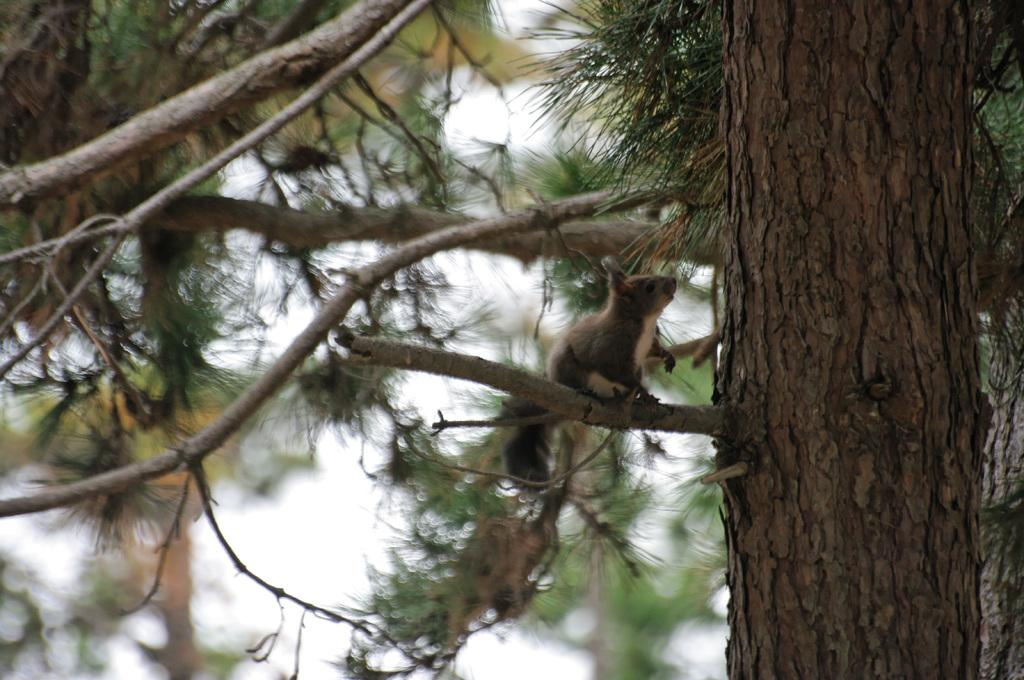What type of animal is in the image? There is a brown squirrel in the image. Where is the squirrel located? The squirrel is sitting on a tree branch. What color are the leaves visible in the image? There are green leaves visible in the image. What can be seen in the right corner of the image? There is a tree trunk in the right corner of the image. What type of crack is the squirrel trying to fix in the image? There is no crack present in the image; it features a brown squirrel sitting on a tree branch. Who is taking care of the squirrel in the image? There is no indication in the image that the squirrel is being taken care of by anyone. 